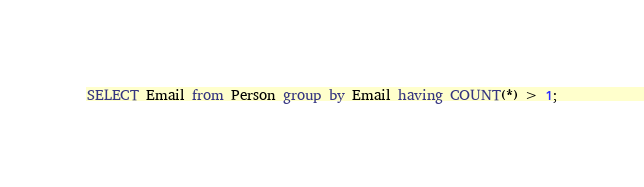<code> <loc_0><loc_0><loc_500><loc_500><_SQL_>SELECT Email from Person group by Email having COUNT(*) > 1;
</code> 